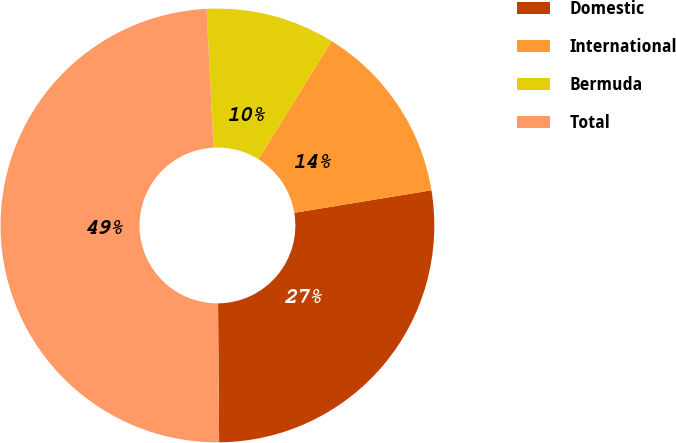Convert chart. <chart><loc_0><loc_0><loc_500><loc_500><pie_chart><fcel>Domestic<fcel>International<fcel>Bermuda<fcel>Total<nl><fcel>27.47%<fcel>13.59%<fcel>9.62%<fcel>49.32%<nl></chart> 